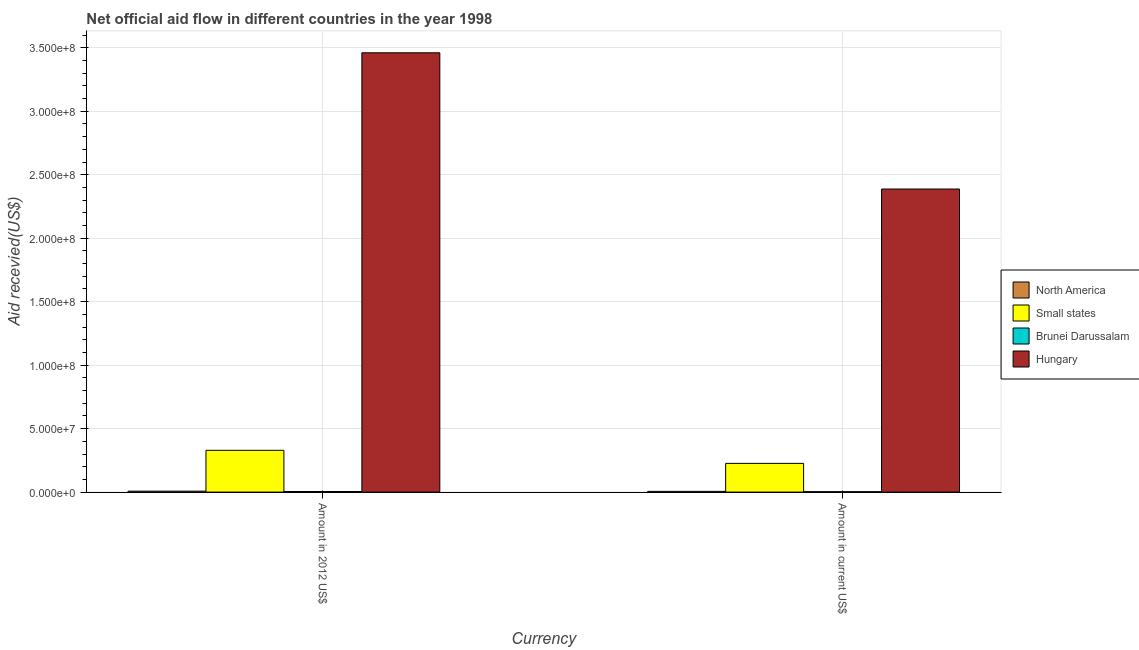How many groups of bars are there?
Offer a very short reply. 2. Are the number of bars per tick equal to the number of legend labels?
Make the answer very short. Yes. How many bars are there on the 2nd tick from the right?
Offer a very short reply. 4. What is the label of the 2nd group of bars from the left?
Ensure brevity in your answer.  Amount in current US$. What is the amount of aid received(expressed in us$) in Brunei Darussalam?
Provide a succinct answer. 3.30e+05. Across all countries, what is the maximum amount of aid received(expressed in 2012 us$)?
Your answer should be compact. 3.46e+08. Across all countries, what is the minimum amount of aid received(expressed in us$)?
Your answer should be compact. 3.30e+05. In which country was the amount of aid received(expressed in us$) maximum?
Your response must be concise. Hungary. In which country was the amount of aid received(expressed in us$) minimum?
Ensure brevity in your answer.  Brunei Darussalam. What is the total amount of aid received(expressed in 2012 us$) in the graph?
Keep it short and to the point. 3.80e+08. What is the difference between the amount of aid received(expressed in 2012 us$) in Brunei Darussalam and that in Small states?
Provide a succinct answer. -3.24e+07. What is the difference between the amount of aid received(expressed in 2012 us$) in Hungary and the amount of aid received(expressed in us$) in North America?
Your answer should be compact. 3.46e+08. What is the average amount of aid received(expressed in 2012 us$) per country?
Provide a short and direct response. 9.50e+07. What is the difference between the amount of aid received(expressed in us$) and amount of aid received(expressed in 2012 us$) in Hungary?
Give a very brief answer. -1.07e+08. In how many countries, is the amount of aid received(expressed in us$) greater than 310000000 US$?
Provide a short and direct response. 0. What is the ratio of the amount of aid received(expressed in us$) in Hungary to that in North America?
Offer a very short reply. 434.09. Is the amount of aid received(expressed in 2012 us$) in North America less than that in Hungary?
Give a very brief answer. Yes. In how many countries, is the amount of aid received(expressed in us$) greater than the average amount of aid received(expressed in us$) taken over all countries?
Offer a terse response. 1. What does the 4th bar from the left in Amount in 2012 US$ represents?
Your response must be concise. Hungary. What does the 2nd bar from the right in Amount in current US$ represents?
Give a very brief answer. Brunei Darussalam. Does the graph contain any zero values?
Offer a very short reply. No. What is the title of the graph?
Make the answer very short. Net official aid flow in different countries in the year 1998. What is the label or title of the X-axis?
Make the answer very short. Currency. What is the label or title of the Y-axis?
Offer a very short reply. Aid recevied(US$). What is the Aid recevied(US$) of North America in Amount in 2012 US$?
Offer a very short reply. 7.40e+05. What is the Aid recevied(US$) in Small states in Amount in 2012 US$?
Offer a terse response. 3.29e+07. What is the Aid recevied(US$) of Hungary in Amount in 2012 US$?
Provide a short and direct response. 3.46e+08. What is the Aid recevied(US$) in North America in Amount in current US$?
Offer a very short reply. 5.50e+05. What is the Aid recevied(US$) of Small states in Amount in current US$?
Provide a short and direct response. 2.26e+07. What is the Aid recevied(US$) in Hungary in Amount in current US$?
Offer a very short reply. 2.39e+08. Across all Currency, what is the maximum Aid recevied(US$) in North America?
Your answer should be very brief. 7.40e+05. Across all Currency, what is the maximum Aid recevied(US$) of Small states?
Provide a succinct answer. 3.29e+07. Across all Currency, what is the maximum Aid recevied(US$) of Hungary?
Your answer should be very brief. 3.46e+08. Across all Currency, what is the minimum Aid recevied(US$) of Small states?
Your answer should be compact. 2.26e+07. Across all Currency, what is the minimum Aid recevied(US$) of Hungary?
Offer a very short reply. 2.39e+08. What is the total Aid recevied(US$) in North America in the graph?
Offer a terse response. 1.29e+06. What is the total Aid recevied(US$) of Small states in the graph?
Offer a very short reply. 5.55e+07. What is the total Aid recevied(US$) in Brunei Darussalam in the graph?
Give a very brief answer. 7.90e+05. What is the total Aid recevied(US$) of Hungary in the graph?
Give a very brief answer. 5.85e+08. What is the difference between the Aid recevied(US$) of Small states in Amount in 2012 US$ and that in Amount in current US$?
Give a very brief answer. 1.03e+07. What is the difference between the Aid recevied(US$) of Brunei Darussalam in Amount in 2012 US$ and that in Amount in current US$?
Provide a succinct answer. 1.30e+05. What is the difference between the Aid recevied(US$) in Hungary in Amount in 2012 US$ and that in Amount in current US$?
Give a very brief answer. 1.07e+08. What is the difference between the Aid recevied(US$) of North America in Amount in 2012 US$ and the Aid recevied(US$) of Small states in Amount in current US$?
Your answer should be very brief. -2.19e+07. What is the difference between the Aid recevied(US$) in North America in Amount in 2012 US$ and the Aid recevied(US$) in Brunei Darussalam in Amount in current US$?
Offer a terse response. 4.10e+05. What is the difference between the Aid recevied(US$) in North America in Amount in 2012 US$ and the Aid recevied(US$) in Hungary in Amount in current US$?
Keep it short and to the point. -2.38e+08. What is the difference between the Aid recevied(US$) in Small states in Amount in 2012 US$ and the Aid recevied(US$) in Brunei Darussalam in Amount in current US$?
Make the answer very short. 3.26e+07. What is the difference between the Aid recevied(US$) of Small states in Amount in 2012 US$ and the Aid recevied(US$) of Hungary in Amount in current US$?
Provide a succinct answer. -2.06e+08. What is the difference between the Aid recevied(US$) of Brunei Darussalam in Amount in 2012 US$ and the Aid recevied(US$) of Hungary in Amount in current US$?
Offer a terse response. -2.38e+08. What is the average Aid recevied(US$) in North America per Currency?
Ensure brevity in your answer.  6.45e+05. What is the average Aid recevied(US$) of Small states per Currency?
Your response must be concise. 2.78e+07. What is the average Aid recevied(US$) of Brunei Darussalam per Currency?
Give a very brief answer. 3.95e+05. What is the average Aid recevied(US$) of Hungary per Currency?
Your answer should be very brief. 2.92e+08. What is the difference between the Aid recevied(US$) of North America and Aid recevied(US$) of Small states in Amount in 2012 US$?
Offer a terse response. -3.22e+07. What is the difference between the Aid recevied(US$) of North America and Aid recevied(US$) of Hungary in Amount in 2012 US$?
Provide a short and direct response. -3.45e+08. What is the difference between the Aid recevied(US$) in Small states and Aid recevied(US$) in Brunei Darussalam in Amount in 2012 US$?
Offer a very short reply. 3.24e+07. What is the difference between the Aid recevied(US$) of Small states and Aid recevied(US$) of Hungary in Amount in 2012 US$?
Give a very brief answer. -3.13e+08. What is the difference between the Aid recevied(US$) in Brunei Darussalam and Aid recevied(US$) in Hungary in Amount in 2012 US$?
Provide a succinct answer. -3.46e+08. What is the difference between the Aid recevied(US$) in North America and Aid recevied(US$) in Small states in Amount in current US$?
Your response must be concise. -2.21e+07. What is the difference between the Aid recevied(US$) in North America and Aid recevied(US$) in Hungary in Amount in current US$?
Your answer should be compact. -2.38e+08. What is the difference between the Aid recevied(US$) in Small states and Aid recevied(US$) in Brunei Darussalam in Amount in current US$?
Provide a succinct answer. 2.23e+07. What is the difference between the Aid recevied(US$) of Small states and Aid recevied(US$) of Hungary in Amount in current US$?
Provide a short and direct response. -2.16e+08. What is the difference between the Aid recevied(US$) in Brunei Darussalam and Aid recevied(US$) in Hungary in Amount in current US$?
Your answer should be very brief. -2.38e+08. What is the ratio of the Aid recevied(US$) in North America in Amount in 2012 US$ to that in Amount in current US$?
Make the answer very short. 1.35. What is the ratio of the Aid recevied(US$) in Small states in Amount in 2012 US$ to that in Amount in current US$?
Offer a terse response. 1.46. What is the ratio of the Aid recevied(US$) in Brunei Darussalam in Amount in 2012 US$ to that in Amount in current US$?
Keep it short and to the point. 1.39. What is the ratio of the Aid recevied(US$) in Hungary in Amount in 2012 US$ to that in Amount in current US$?
Give a very brief answer. 1.45. What is the difference between the highest and the second highest Aid recevied(US$) in North America?
Your response must be concise. 1.90e+05. What is the difference between the highest and the second highest Aid recevied(US$) of Small states?
Ensure brevity in your answer.  1.03e+07. What is the difference between the highest and the second highest Aid recevied(US$) of Hungary?
Provide a succinct answer. 1.07e+08. What is the difference between the highest and the lowest Aid recevied(US$) of Small states?
Ensure brevity in your answer.  1.03e+07. What is the difference between the highest and the lowest Aid recevied(US$) in Hungary?
Provide a short and direct response. 1.07e+08. 